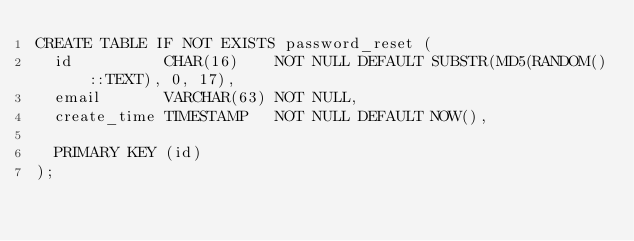<code> <loc_0><loc_0><loc_500><loc_500><_SQL_>CREATE TABLE IF NOT EXISTS password_reset (
  id          CHAR(16)    NOT NULL DEFAULT SUBSTR(MD5(RANDOM()::TEXT), 0, 17),
  email       VARCHAR(63) NOT NULL,
  create_time TIMESTAMP   NOT NULL DEFAULT NOW(),

  PRIMARY KEY (id)
);
</code> 